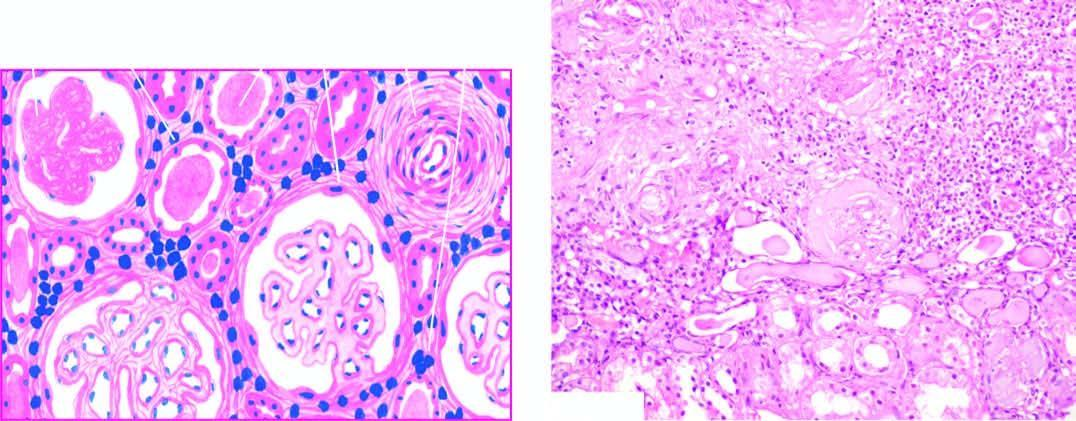what are surrounded by abundant fibrous tissue and chronic interstitial inflammatory reaction?
Answer the question using a single word or phrase. Tubules 